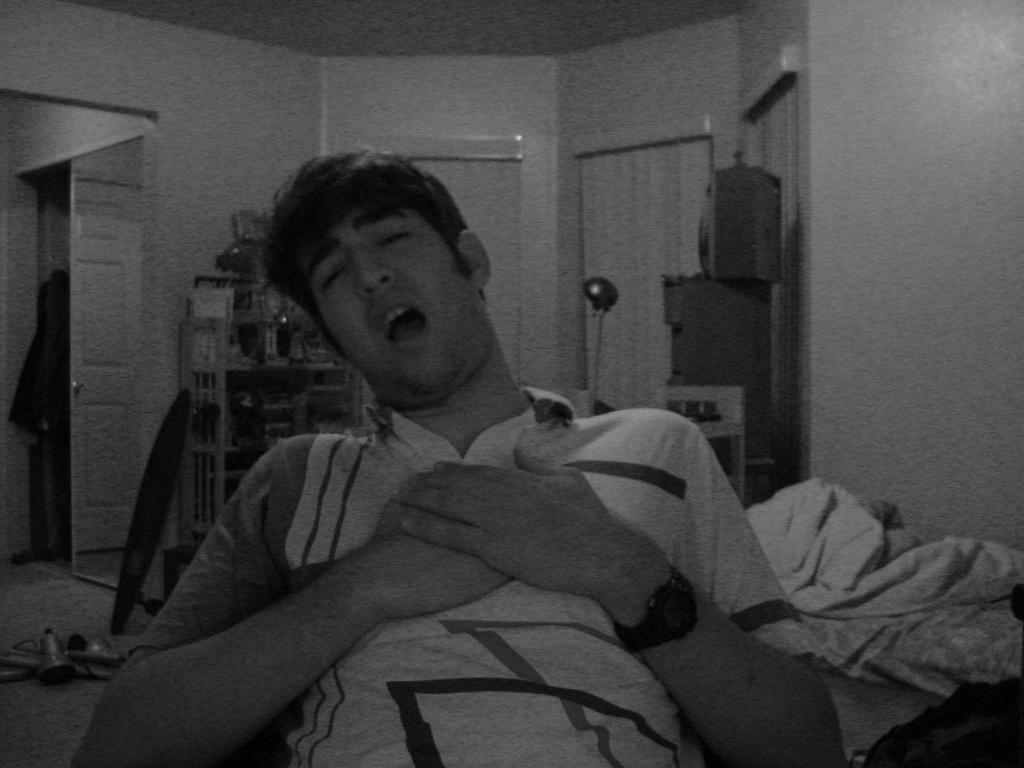What is the color scheme of the image? The image is black and white. Can you describe the main subject in the image? There is a person in the image. What can be seen in the background of the image? There is a wall, curtains, a door, and other objects in the background of the image. What type of polish is the person applying to their teeth in the image? There is no indication in the image that the person is applying any polish to their teeth, as the image is black and white and does not show any teeth or polishing activity. 